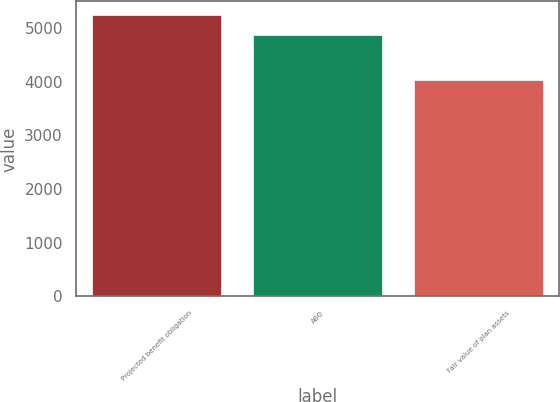Convert chart. <chart><loc_0><loc_0><loc_500><loc_500><bar_chart><fcel>Projected benefit obligation<fcel>ABO<fcel>Fair value of plan assets<nl><fcel>5233.8<fcel>4864.7<fcel>4027.9<nl></chart> 